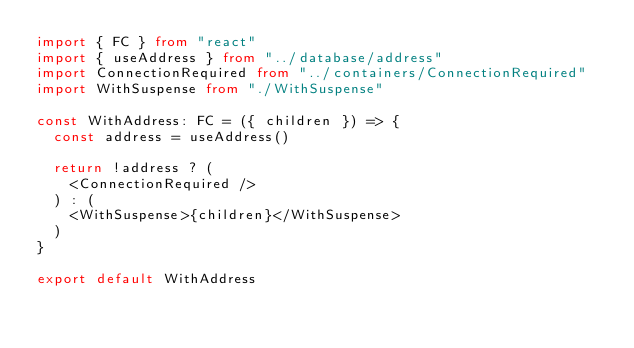<code> <loc_0><loc_0><loc_500><loc_500><_TypeScript_>import { FC } from "react"
import { useAddress } from "../database/address"
import ConnectionRequired from "../containers/ConnectionRequired"
import WithSuspense from "./WithSuspense"

const WithAddress: FC = ({ children }) => {
  const address = useAddress()

  return !address ? (
    <ConnectionRequired />
  ) : (
    <WithSuspense>{children}</WithSuspense>
  )
}

export default WithAddress
</code> 